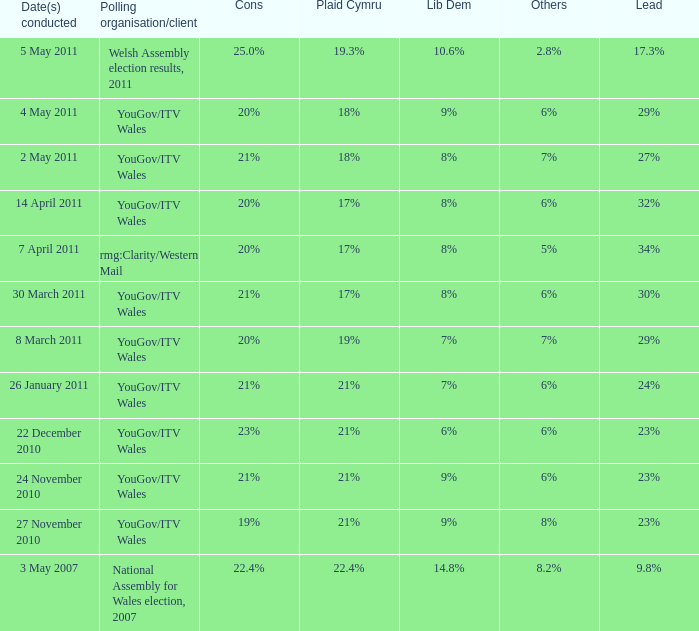I want the lead for others being 5% 34%. I'm looking to parse the entire table for insights. Could you assist me with that? {'header': ['Date(s) conducted', 'Polling organisation/client', 'Cons', 'Plaid Cymru', 'Lib Dem', 'Others', 'Lead'], 'rows': [['5 May 2011', 'Welsh Assembly election results, 2011', '25.0%', '19.3%', '10.6%', '2.8%', '17.3%'], ['4 May 2011', 'YouGov/ITV Wales', '20%', '18%', '9%', '6%', '29%'], ['2 May 2011', 'YouGov/ITV Wales', '21%', '18%', '8%', '7%', '27%'], ['14 April 2011', 'YouGov/ITV Wales', '20%', '17%', '8%', '6%', '32%'], ['7 April 2011', 'rmg:Clarity/Western Mail', '20%', '17%', '8%', '5%', '34%'], ['30 March 2011', 'YouGov/ITV Wales', '21%', '17%', '8%', '6%', '30%'], ['8 March 2011', 'YouGov/ITV Wales', '20%', '19%', '7%', '7%', '29%'], ['26 January 2011', 'YouGov/ITV Wales', '21%', '21%', '7%', '6%', '24%'], ['22 December 2010', 'YouGov/ITV Wales', '23%', '21%', '6%', '6%', '23%'], ['24 November 2010', 'YouGov/ITV Wales', '21%', '21%', '9%', '6%', '23%'], ['27 November 2010', 'YouGov/ITV Wales', '19%', '21%', '9%', '8%', '23%'], ['3 May 2007', 'National Assembly for Wales election, 2007', '22.4%', '22.4%', '14.8%', '8.2%', '9.8%']]} 